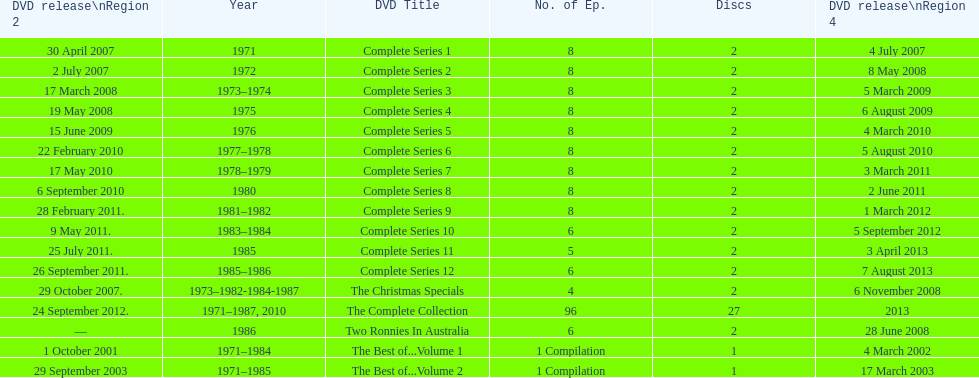How many "best of" volumes compile the top episodes of the television show "the two ronnies". 2. 